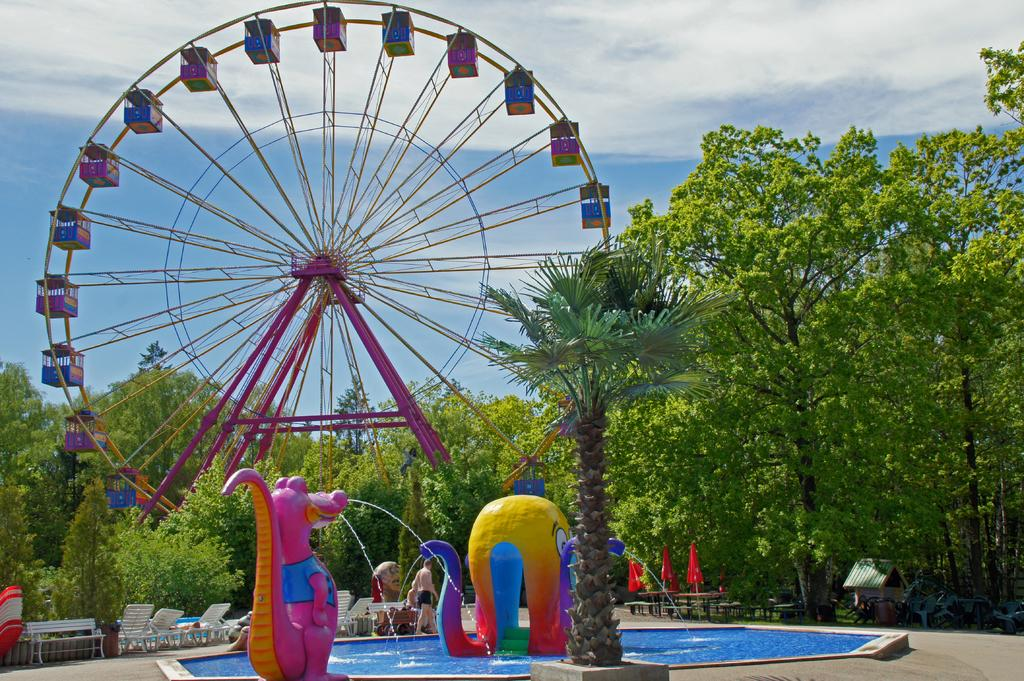What is the most prominent feature in the image? There is a giant wheelchair in the image. What type of natural environment is visible in the image? There are trees and water visible in the image. What can be seen flying in the image? There are flags in the image. What part of the natural environment is visible in the image? The sky is visible in the image. What other objects can be seen in the image besides the giant wheelchair? There are other objects present in the image. What type of sleet is falling from the sky in the image? There is no sleet visible in the image; the sky is clear. What type of chair is used for sitting in the image? The image features a giant wheelchair, which is not a typical chair for sitting. 